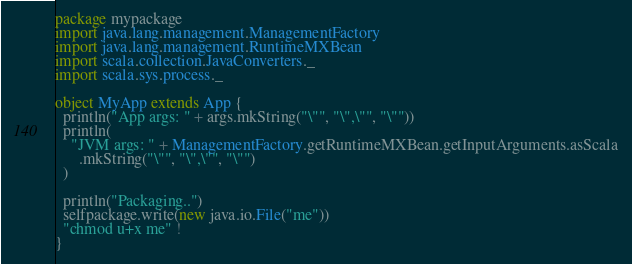Convert code to text. <code><loc_0><loc_0><loc_500><loc_500><_Scala_>package mypackage
import java.lang.management.ManagementFactory
import java.lang.management.RuntimeMXBean
import scala.collection.JavaConverters._
import scala.sys.process._

object MyApp extends App {
  println("App args: " + args.mkString("\"", "\",\"", "\""))
  println(
    "JVM args: " + ManagementFactory.getRuntimeMXBean.getInputArguments.asScala
      .mkString("\"", "\",\"", "\"")
  )

  println("Packaging..")
  selfpackage.write(new java.io.File("me"))
  "chmod u+x me" !
}
</code> 